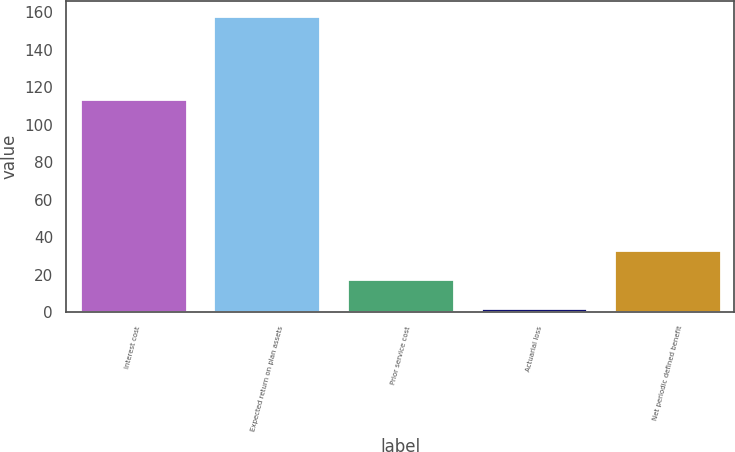<chart> <loc_0><loc_0><loc_500><loc_500><bar_chart><fcel>Interest cost<fcel>Expected return on plan assets<fcel>Prior service cost<fcel>Actuarial loss<fcel>Net periodic defined benefit<nl><fcel>114<fcel>158<fcel>17.6<fcel>2<fcel>33.2<nl></chart> 